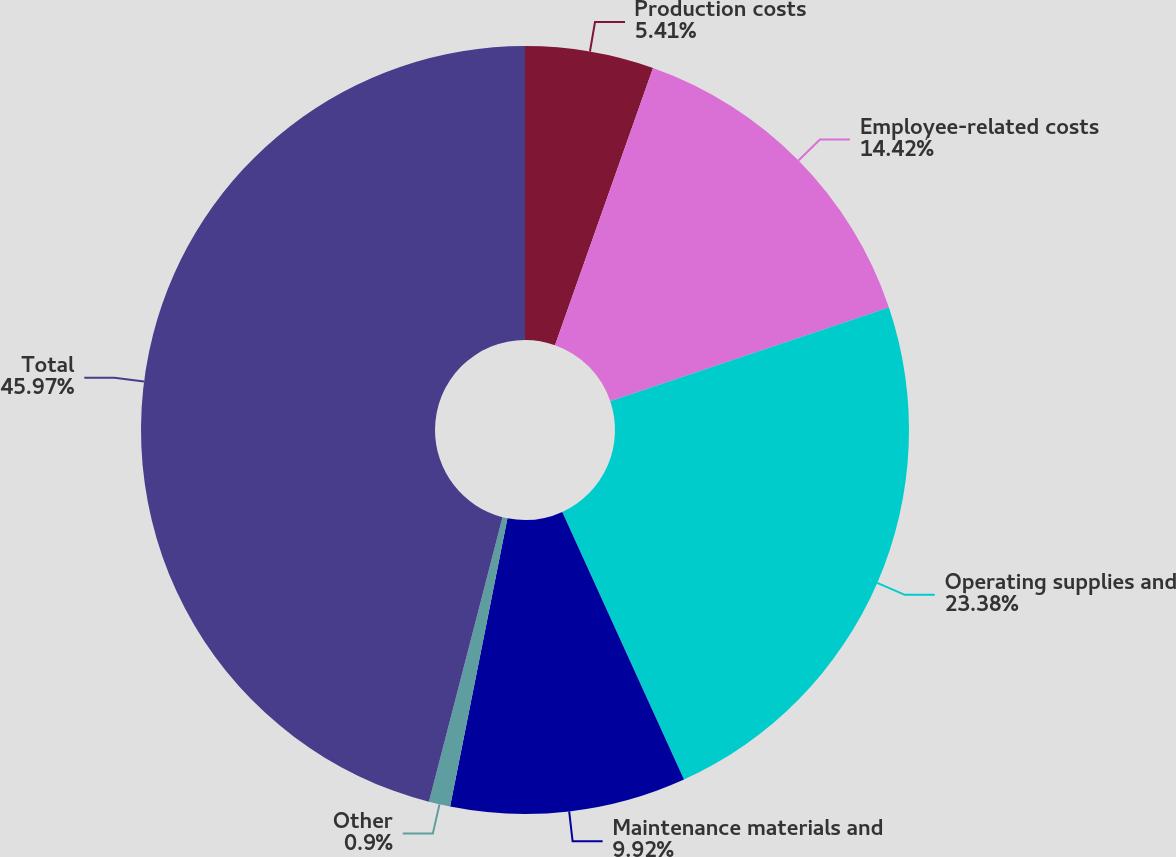Convert chart. <chart><loc_0><loc_0><loc_500><loc_500><pie_chart><fcel>Production costs<fcel>Employee-related costs<fcel>Operating supplies and<fcel>Maintenance materials and<fcel>Other<fcel>Total<nl><fcel>5.41%<fcel>14.42%<fcel>23.38%<fcel>9.92%<fcel>0.9%<fcel>45.98%<nl></chart> 